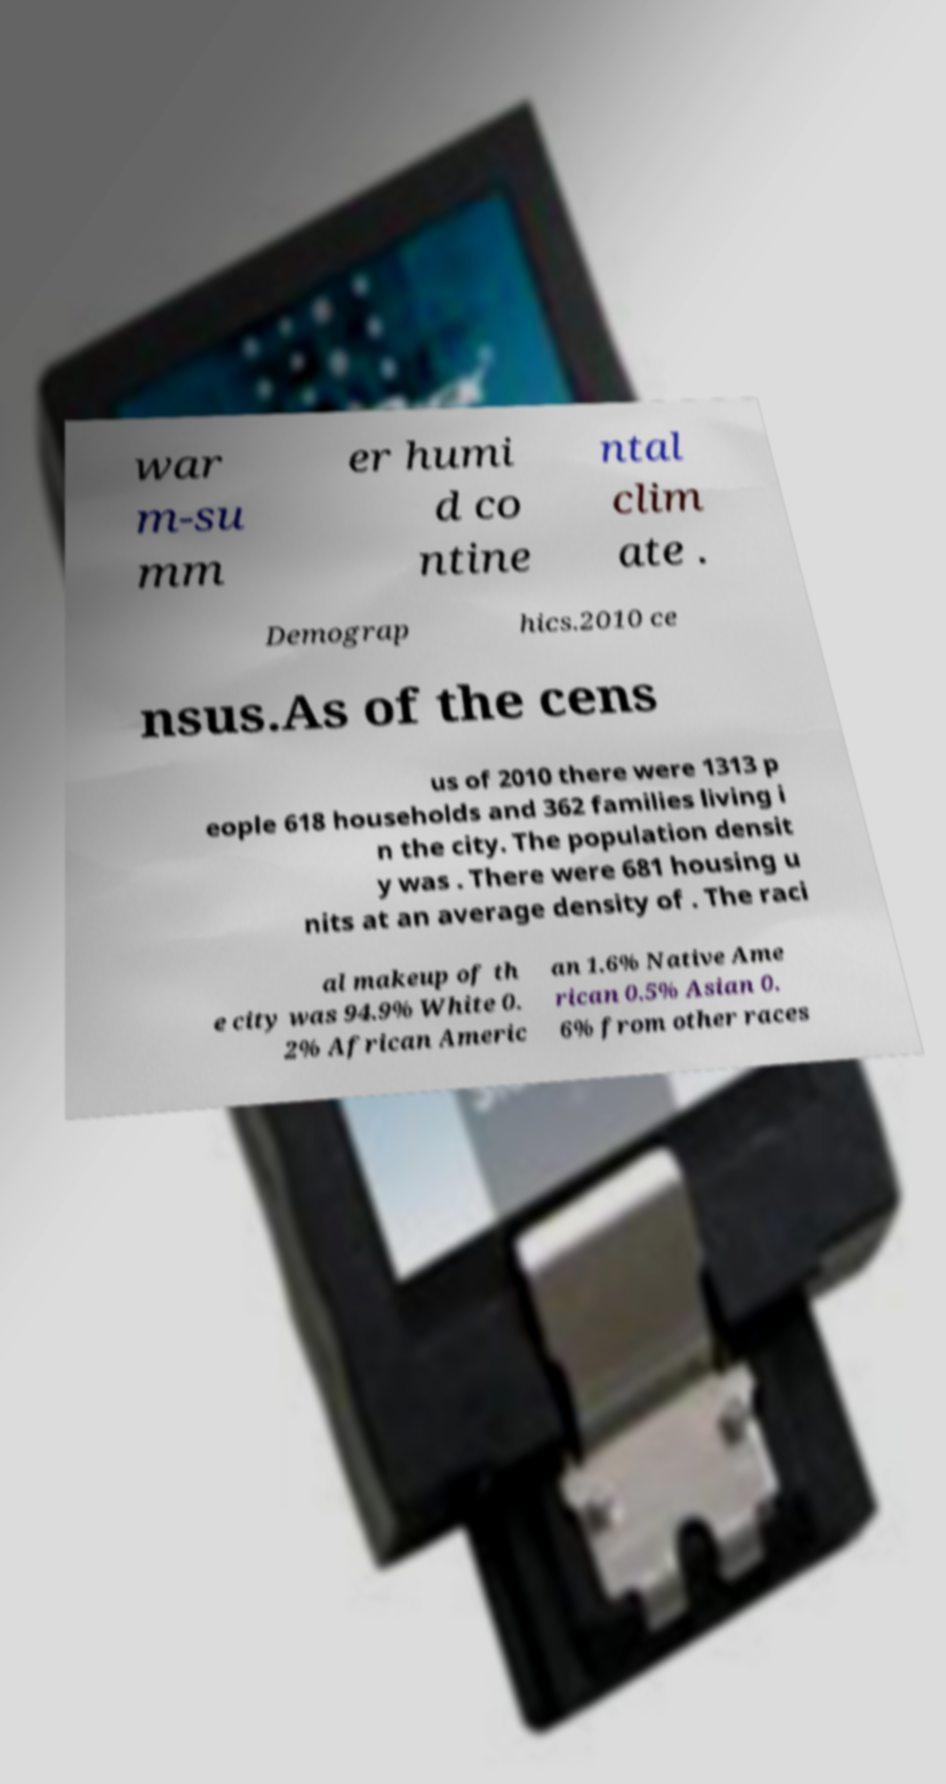Can you read and provide the text displayed in the image?This photo seems to have some interesting text. Can you extract and type it out for me? war m-su mm er humi d co ntine ntal clim ate . Demograp hics.2010 ce nsus.As of the cens us of 2010 there were 1313 p eople 618 households and 362 families living i n the city. The population densit y was . There were 681 housing u nits at an average density of . The raci al makeup of th e city was 94.9% White 0. 2% African Americ an 1.6% Native Ame rican 0.5% Asian 0. 6% from other races 